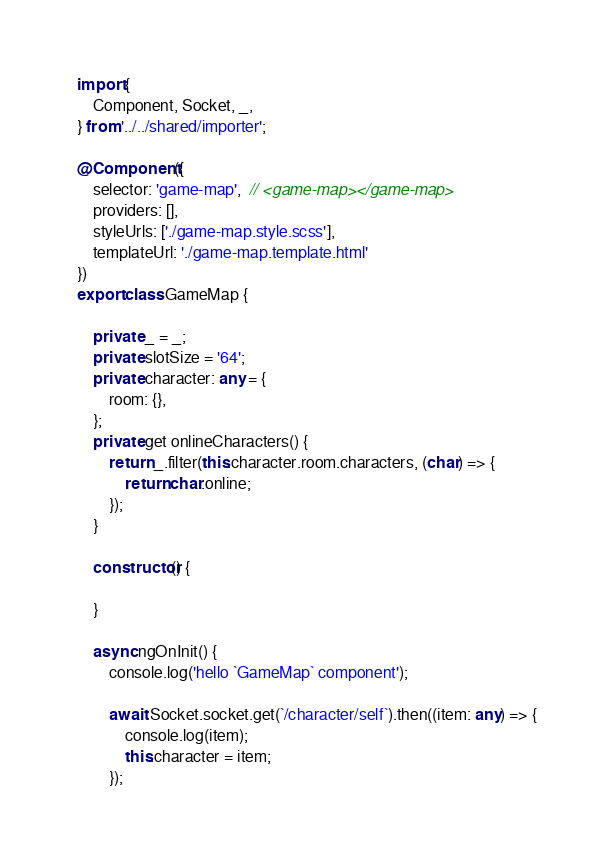<code> <loc_0><loc_0><loc_500><loc_500><_TypeScript_>import {
    Component, Socket, _,
} from '../../shared/importer';

@Component({
    selector: 'game-map',  // <game-map></game-map>
    providers: [],
    styleUrls: ['./game-map.style.scss'],
    templateUrl: './game-map.template.html'
})
export class GameMap {

    private _ = _;
    private slotSize = '64';
    private character: any = {
        room: {},
    };
    private get onlineCharacters() {
        return _.filter(this.character.room.characters, (char) => {
            return char.online;
        });
    }

    constructor() {

    }

    async ngOnInit() {
        console.log('hello `GameMap` component');

        await Socket.socket.get(`/character/self`).then((item: any) => {
            console.log(item);
            this.character = item;
        });
</code> 